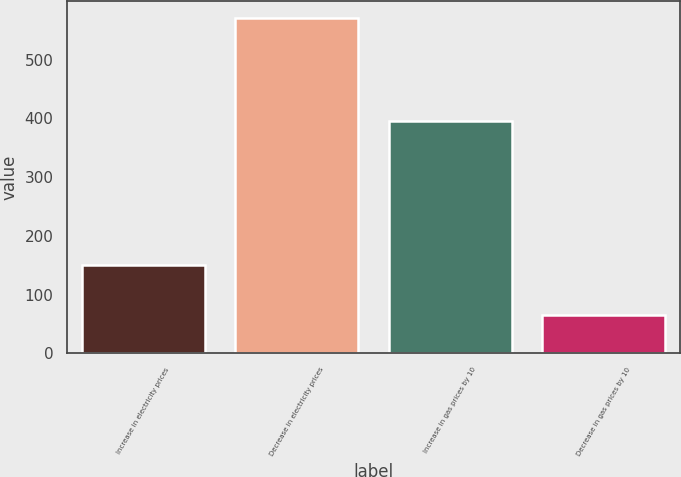<chart> <loc_0><loc_0><loc_500><loc_500><bar_chart><fcel>Increase in electricity prices<fcel>Decrease in electricity prices<fcel>Increase in gas prices by 10<fcel>Decrease in gas prices by 10<nl><fcel>150<fcel>571<fcel>396<fcel>65<nl></chart> 